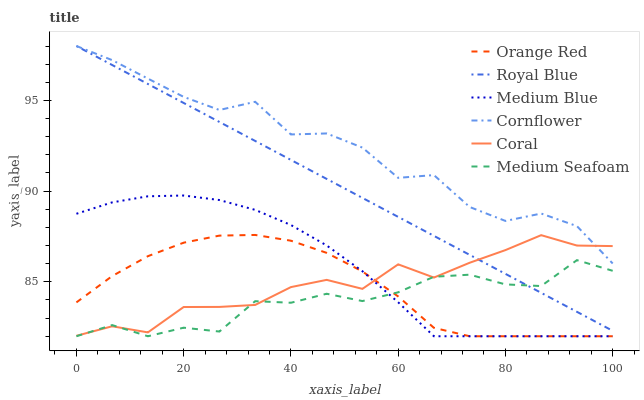Does Medium Seafoam have the minimum area under the curve?
Answer yes or no. Yes. Does Cornflower have the maximum area under the curve?
Answer yes or no. Yes. Does Coral have the minimum area under the curve?
Answer yes or no. No. Does Coral have the maximum area under the curve?
Answer yes or no. No. Is Royal Blue the smoothest?
Answer yes or no. Yes. Is Cornflower the roughest?
Answer yes or no. Yes. Is Coral the smoothest?
Answer yes or no. No. Is Coral the roughest?
Answer yes or no. No. Does Medium Blue have the lowest value?
Answer yes or no. Yes. Does Coral have the lowest value?
Answer yes or no. No. Does Royal Blue have the highest value?
Answer yes or no. Yes. Does Coral have the highest value?
Answer yes or no. No. Is Medium Seafoam less than Cornflower?
Answer yes or no. Yes. Is Cornflower greater than Orange Red?
Answer yes or no. Yes. Does Coral intersect Royal Blue?
Answer yes or no. Yes. Is Coral less than Royal Blue?
Answer yes or no. No. Is Coral greater than Royal Blue?
Answer yes or no. No. Does Medium Seafoam intersect Cornflower?
Answer yes or no. No. 